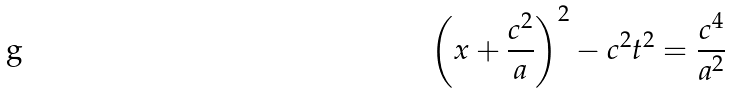<formula> <loc_0><loc_0><loc_500><loc_500>\left ( x + \frac { c ^ { 2 } } { a } \right ) ^ { 2 } - c ^ { 2 } t ^ { 2 } = \frac { c ^ { 4 } } { a ^ { 2 } }</formula> 